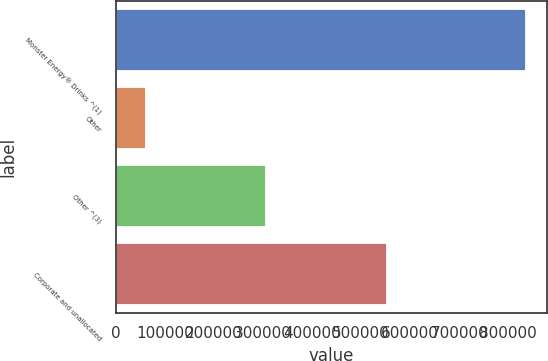<chart> <loc_0><loc_0><loc_500><loc_500><bar_chart><fcel>Monster Energy® Drinks ^(1)<fcel>Other<fcel>Other ^(3)<fcel>Corporate and unallocated<nl><fcel>836053<fcel>60777<fcel>306550<fcel>552323<nl></chart> 